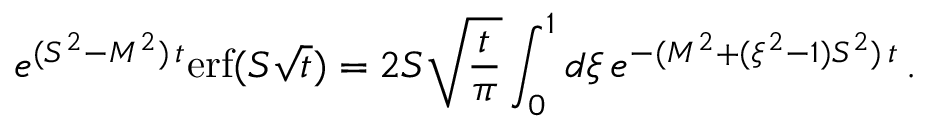Convert formula to latex. <formula><loc_0><loc_0><loc_500><loc_500>e ^ { ( S ^ { 2 } - M ^ { 2 } ) \, t } e r f ( S \sqrt { t } ) = 2 S \sqrt { \frac { t } { \pi } } \int _ { 0 } ^ { 1 } d \xi \, e ^ { - ( M ^ { 2 } + ( \xi ^ { 2 } - 1 ) S ^ { 2 } ) \, t } \, .</formula> 